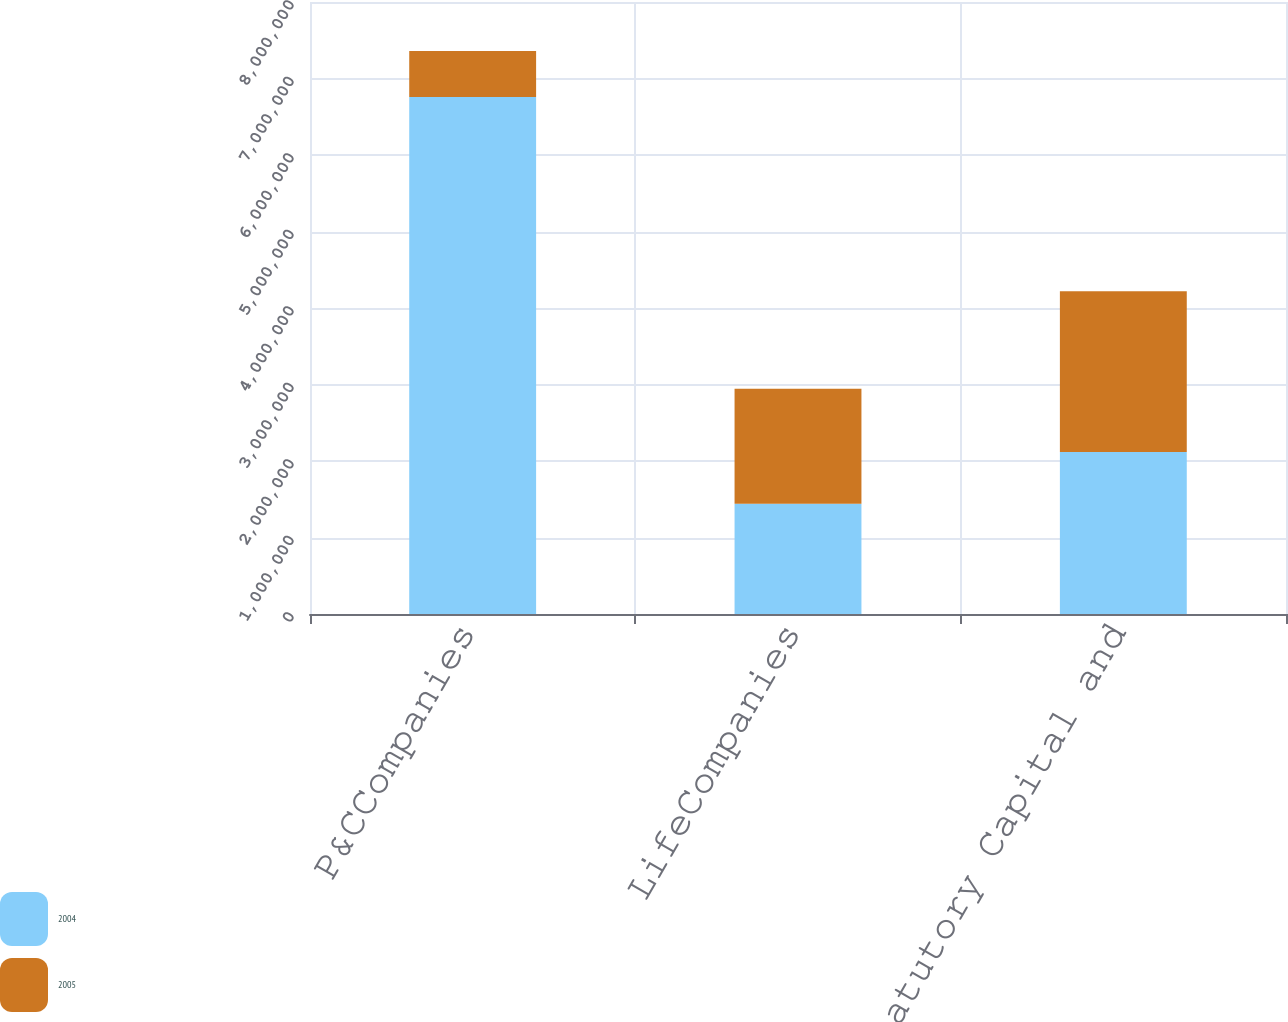Convert chart to OTSL. <chart><loc_0><loc_0><loc_500><loc_500><stacked_bar_chart><ecel><fcel>P&CCompanies<fcel>LifeCompanies<fcel>Total Statutory Capital and<nl><fcel>2004<fcel>6.75971e+06<fcel>1.44218e+06<fcel>2.11815e+06<nl><fcel>2005<fcel>598190<fcel>1.50226e+06<fcel>2.10045e+06<nl></chart> 